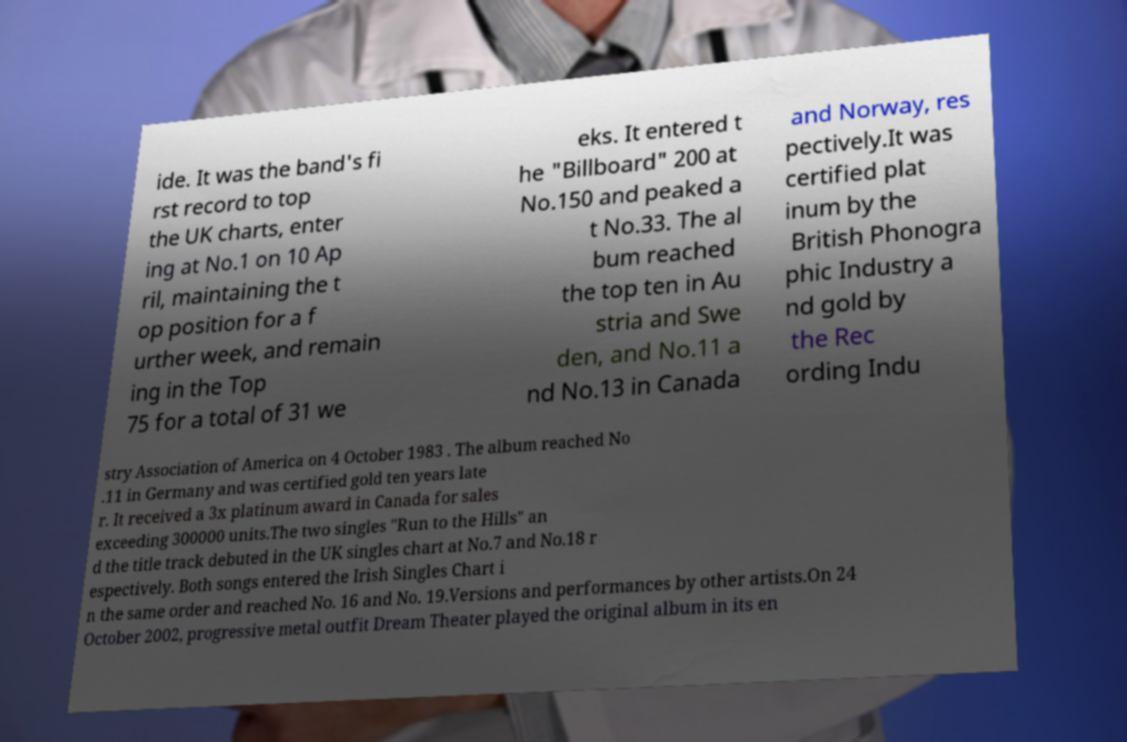Can you read and provide the text displayed in the image?This photo seems to have some interesting text. Can you extract and type it out for me? ide. It was the band's fi rst record to top the UK charts, enter ing at No.1 on 10 Ap ril, maintaining the t op position for a f urther week, and remain ing in the Top 75 for a total of 31 we eks. It entered t he "Billboard" 200 at No.150 and peaked a t No.33. The al bum reached the top ten in Au stria and Swe den, and No.11 a nd No.13 in Canada and Norway, res pectively.It was certified plat inum by the British Phonogra phic Industry a nd gold by the Rec ording Indu stry Association of America on 4 October 1983 . The album reached No .11 in Germany and was certified gold ten years late r. It received a 3x platinum award in Canada for sales exceeding 300000 units.The two singles "Run to the Hills" an d the title track debuted in the UK singles chart at No.7 and No.18 r espectively. Both songs entered the Irish Singles Chart i n the same order and reached No. 16 and No. 19.Versions and performances by other artists.On 24 October 2002, progressive metal outfit Dream Theater played the original album in its en 